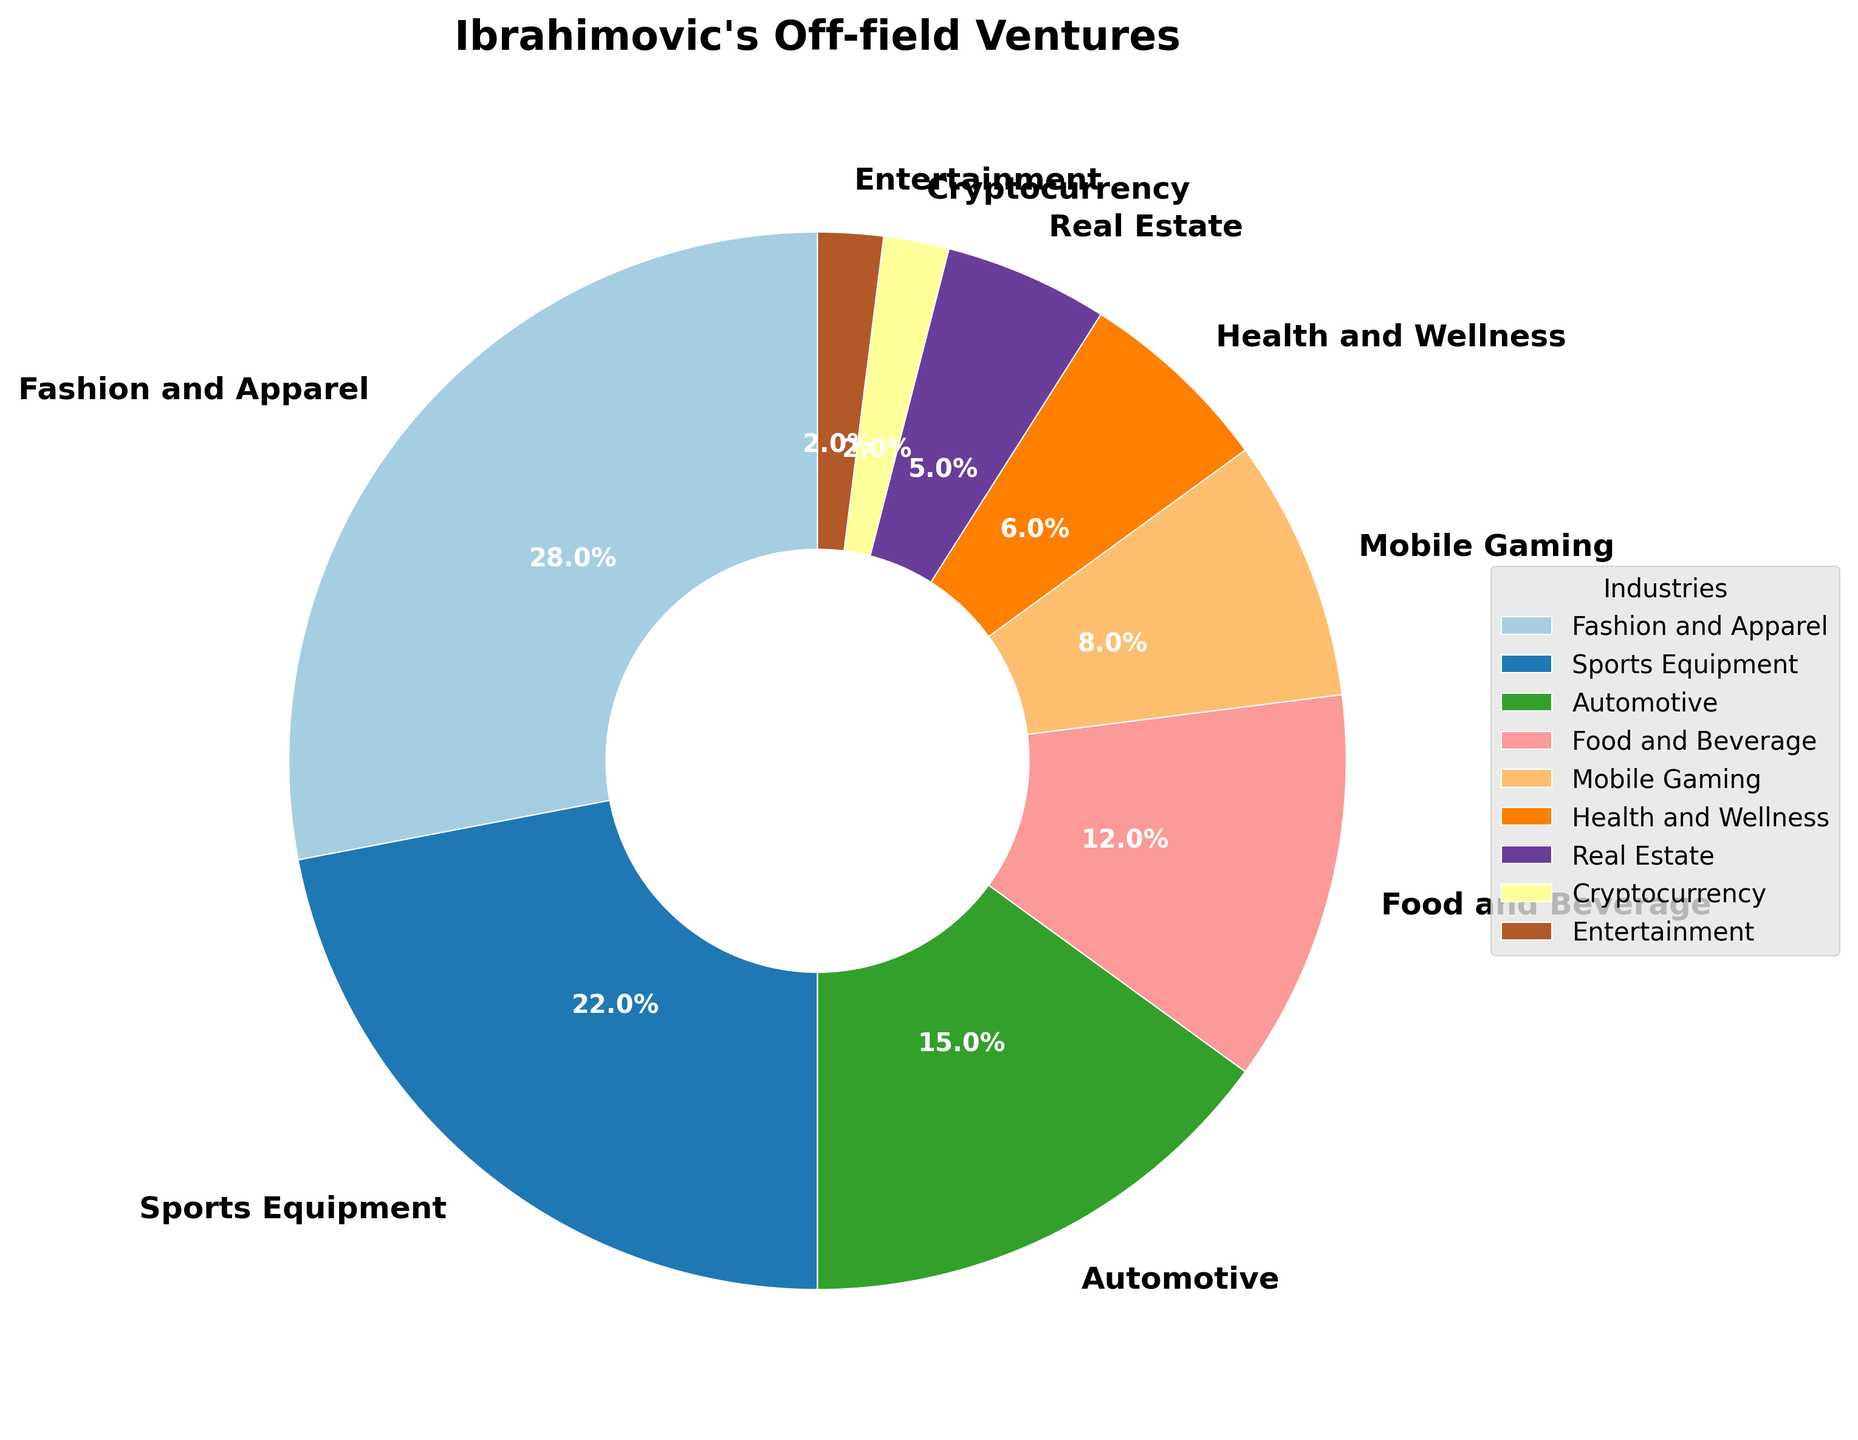What are the top three industries where Ibrahimovic allocates most of his off-field ventures? The top three industries can be determined by identifying the largest percentages in the pie chart. The largest segments are for Fashion and Apparel (28%), Sports Equipment (22%), and Automotive (15%).
Answer: Fashion and Apparel, Sports Equipment, Automotive What is the combined percentage of Ibrahimovic's ventures in the Food and Beverage and Mobile Gaming industries? To find the combined percentage, sum the percentages of Food and Beverage (12%) and Mobile Gaming (8%). 12% + 8% = 20%
Answer: 20% Which industry has the smallest allocation of Ibrahimovic's off-field ventures? By examining the pie chart, the smallest segment is for Cryptocurrency and Entertainment, each with 2%.
Answer: Cryptocurrency, Entertainment Is the percentage allocated to Health and Wellness greater than that of Real Estate? The pie chart shows Health and Wellness with 6% and Real Estate with 5%. Since 6% is greater than 5%, the allocation for Health and Wellness is indeed greater.
Answer: Yes How much more does Ibrahimovic allocate to Fashion and Apparel compared to Real Estate? To find the difference, subtract the percentage of Real Estate (5%) from Fashion and Apparel (28%). 28% - 5% = 23%
Answer: 23% Which industries combined make up more than 50% of Ibrahimovic's off-field ventures? Add the percentages of the top industries until the sum exceeds 50%. Fashion and Apparel (28%) + Sports Equipment (22%) = 50%. Adding the next largest percentage, Automotive (15%), results in 65%, which is greater than 50%. So, Fashion and Apparel, Sports Equipment, and Automotive combined make up more than 50%.
Answer: Fashion and Apparel, Sports Equipment, Automotive Are there any industries in the pie chart with an equal percentage allocation? By examining the chart, Cryptocurrency and Entertainment each have a 2% allocation.
Answer: Yes Which segment in the pie chart is represented by the color likely derived from the midpoint of the Paired colormap? This requires identifying the middle segment in terms of size in the pie chart created using the Paired colormap. The middle pie segment is for the Food and Beverage industry with 12%.
Answer: Food and Beverage What is the difference in allocation percentage between the Health and Wellness and Sports Equipment industries? Subtract the percentage for Health and Wellness (6%) from Sports Equipment (22%). 22% - 6% = 16%
Answer: 16% 